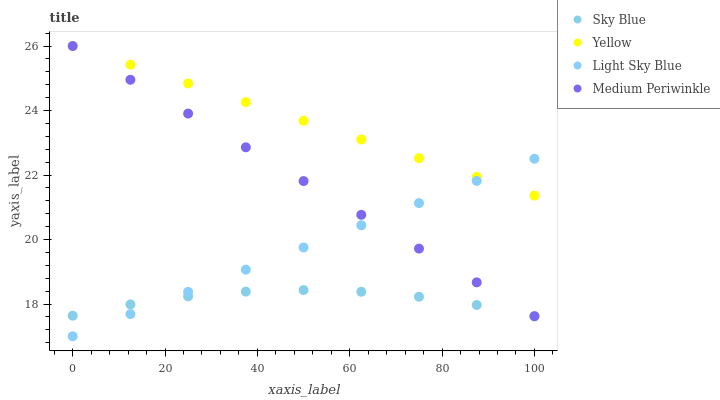Does Sky Blue have the minimum area under the curve?
Answer yes or no. Yes. Does Yellow have the maximum area under the curve?
Answer yes or no. Yes. Does Light Sky Blue have the minimum area under the curve?
Answer yes or no. No. Does Light Sky Blue have the maximum area under the curve?
Answer yes or no. No. Is Yellow the smoothest?
Answer yes or no. Yes. Is Sky Blue the roughest?
Answer yes or no. Yes. Is Light Sky Blue the smoothest?
Answer yes or no. No. Is Light Sky Blue the roughest?
Answer yes or no. No. Does Light Sky Blue have the lowest value?
Answer yes or no. Yes. Does Medium Periwinkle have the lowest value?
Answer yes or no. No. Does Yellow have the highest value?
Answer yes or no. Yes. Does Light Sky Blue have the highest value?
Answer yes or no. No. Is Sky Blue less than Yellow?
Answer yes or no. Yes. Is Yellow greater than Sky Blue?
Answer yes or no. Yes. Does Light Sky Blue intersect Yellow?
Answer yes or no. Yes. Is Light Sky Blue less than Yellow?
Answer yes or no. No. Is Light Sky Blue greater than Yellow?
Answer yes or no. No. Does Sky Blue intersect Yellow?
Answer yes or no. No. 